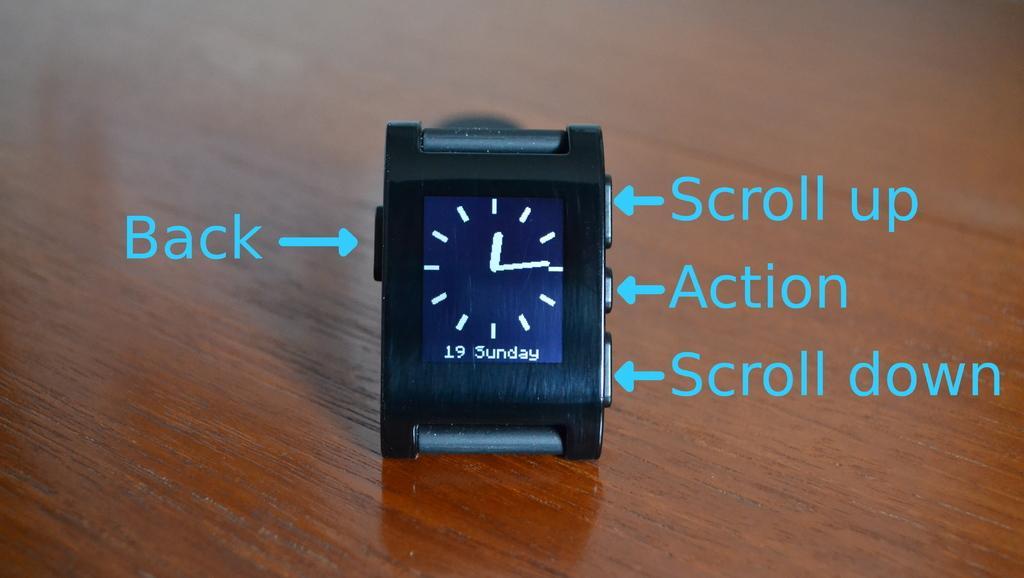Describe this image in one or two sentences. In this picture there is a watch placed on a wooden desk. Towards right there are arrows and text. Towards left there is an arrow and text. 